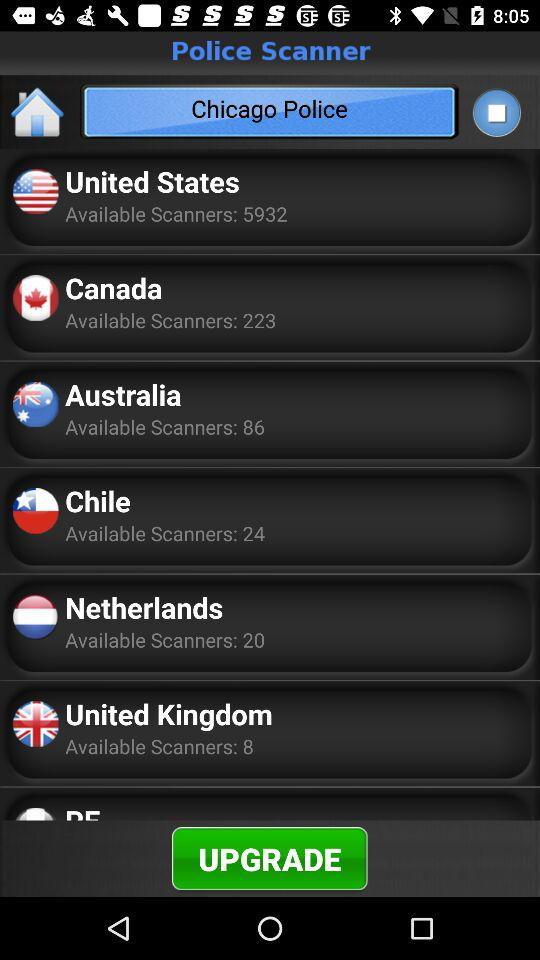How many more scanners are available in the United States than in Canada?
Answer the question using a single word or phrase. 5709 